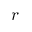<formula> <loc_0><loc_0><loc_500><loc_500>r</formula> 